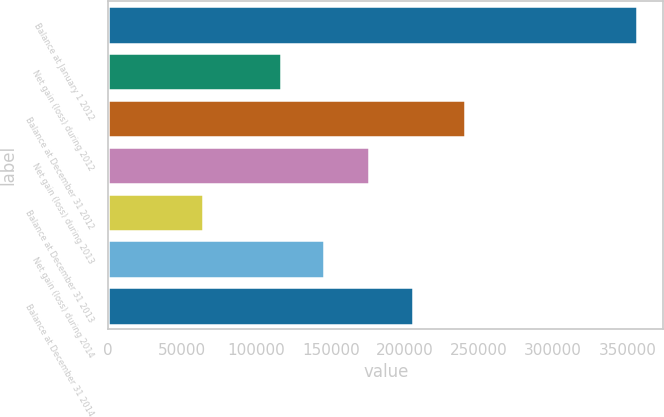<chart> <loc_0><loc_0><loc_500><loc_500><bar_chart><fcel>Balance at January 1 2012<fcel>Net gain (loss) during 2012<fcel>Balance at December 31 2012<fcel>Net gain (loss) during 2013<fcel>Balance at December 31 2013<fcel>Net gain (loss) during 2014<fcel>Balance at December 31 2014<nl><fcel>356441<fcel>116177<fcel>240264<fcel>176105<fcel>64159<fcel>145405<fcel>205333<nl></chart> 